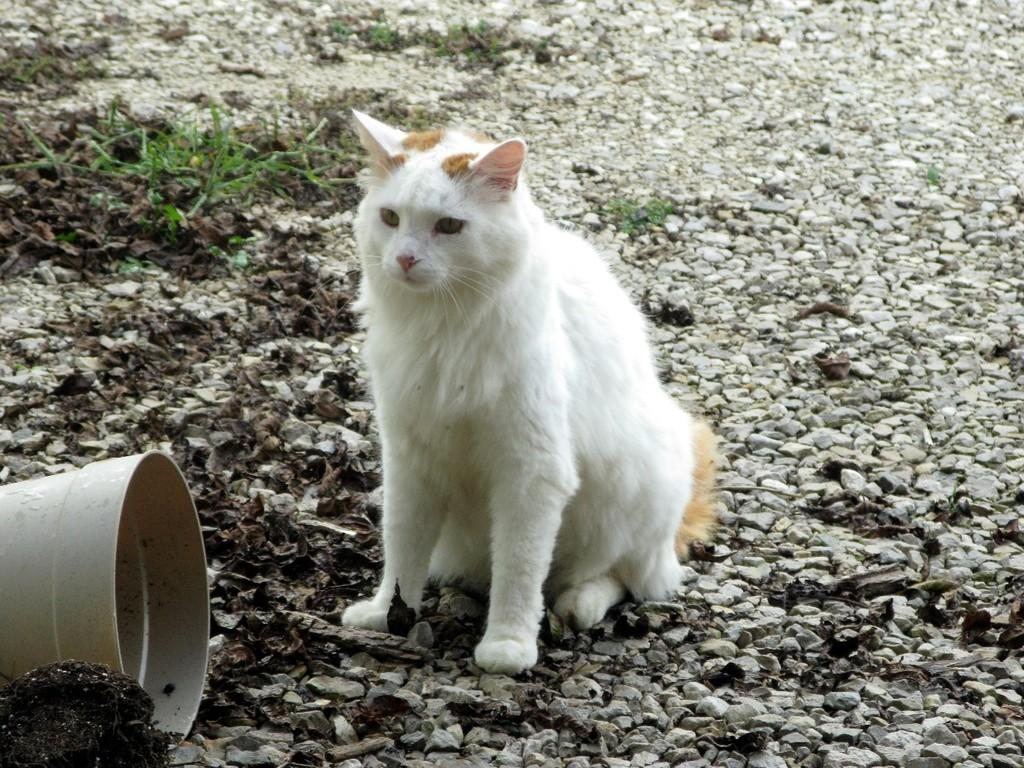What type of animal is in the image? There is a white-colored cat in the image. What type of vegetation can be seen in the image? There is grass visible in the image. What object can be seen in the image? There is a bucket in the image. What type of plantation can be seen in the image? There is no plantation present in the image; it features a white-colored cat, grass, and a bucket. 